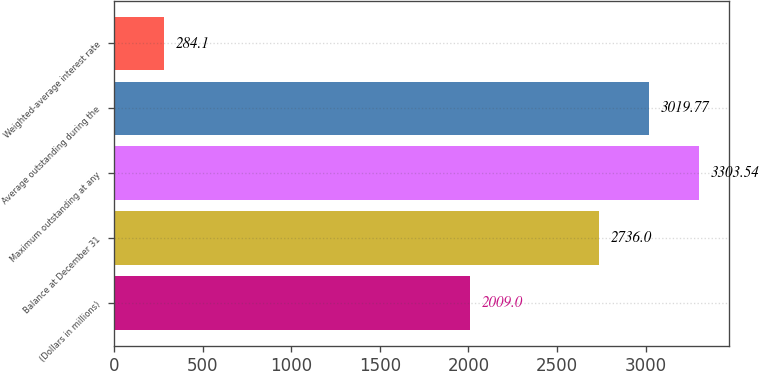Convert chart to OTSL. <chart><loc_0><loc_0><loc_500><loc_500><bar_chart><fcel>(Dollars in millions)<fcel>Balance at December 31<fcel>Maximum outstanding at any<fcel>Average outstanding during the<fcel>Weighted-average interest rate<nl><fcel>2009<fcel>2736<fcel>3303.54<fcel>3019.77<fcel>284.1<nl></chart> 